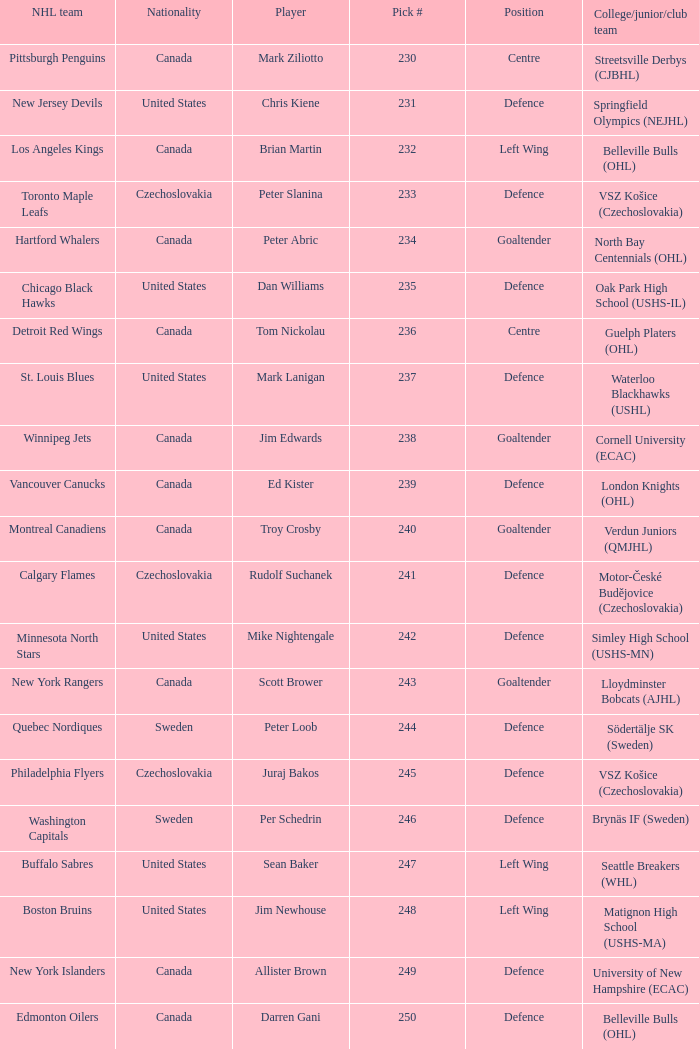What selection was the springfield olympics (nejhl)? 231.0. 